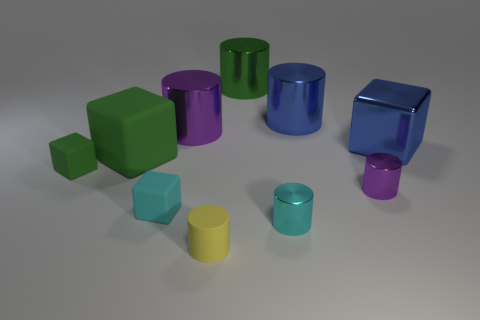Subtract 3 cylinders. How many cylinders are left? 3 Subtract all blue cylinders. How many cylinders are left? 5 Subtract all cyan cylinders. How many cylinders are left? 5 Subtract all red blocks. Subtract all blue cylinders. How many blocks are left? 4 Subtract all cubes. How many objects are left? 6 Subtract all big metallic blocks. Subtract all blue objects. How many objects are left? 7 Add 5 rubber things. How many rubber things are left? 9 Add 6 green rubber objects. How many green rubber objects exist? 8 Subtract 0 cyan spheres. How many objects are left? 10 